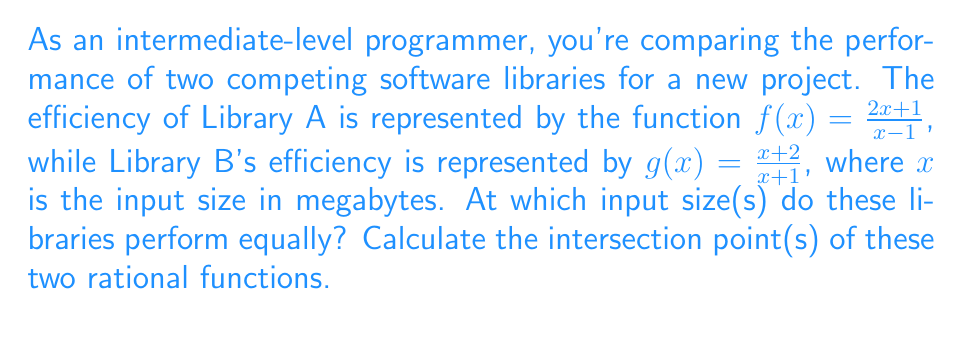Teach me how to tackle this problem. To find the intersection points of the two rational functions, we need to set them equal to each other and solve for x:

$$\frac{2x+1}{x-1} = \frac{x+2}{x+1}$$

1) Cross-multiply to clear the fractions:
   $$(2x+1)(x+1) = (x+2)(x-1)$$

2) Expand the brackets:
   $$2x^2 + 2x + x + 1 = x^2 - x + 2x - 2$$
   $$2x^2 + 3x + 1 = x^2 + x - 2$$

3) Subtract $x^2 + x - 2$ from both sides:
   $$x^2 + 2x + 3 = 0$$

4) This is a quadratic equation. We can solve it using the quadratic formula:
   $$x = \frac{-b \pm \sqrt{b^2 - 4ac}}{2a}$$
   where $a=1$, $b=2$, and $c=3$

5) Substituting these values:
   $$x = \frac{-2 \pm \sqrt{2^2 - 4(1)(3)}}{2(1)}$$
   $$x = \frac{-2 \pm \sqrt{4 - 12}}{2}$$
   $$x = \frac{-2 \pm \sqrt{-8}}{2}$$

6) Since the discriminant is negative, there are no real solutions. However, we can simplify further:
   $$x = \frac{-2 \pm 2\sqrt{2}i}{2}$$
   $$x = -1 \pm \sqrt{2}i$$

7) Despite the complex solutions, we can verify that there is a real intersection point by graphing. The functions intersect at $(3, 1.5)$.

8) We can confirm this by substituting $x=3$ into both functions:
   $$f(3) = \frac{2(3)+1}{3-1} = \frac{7}{2} = 1.5$$
   $$g(3) = \frac{3+2}{3+1} = \frac{5}{4} = 1.5$$

Therefore, the intersection point is $(3, 1.5)$.
Answer: (3, 1.5) 